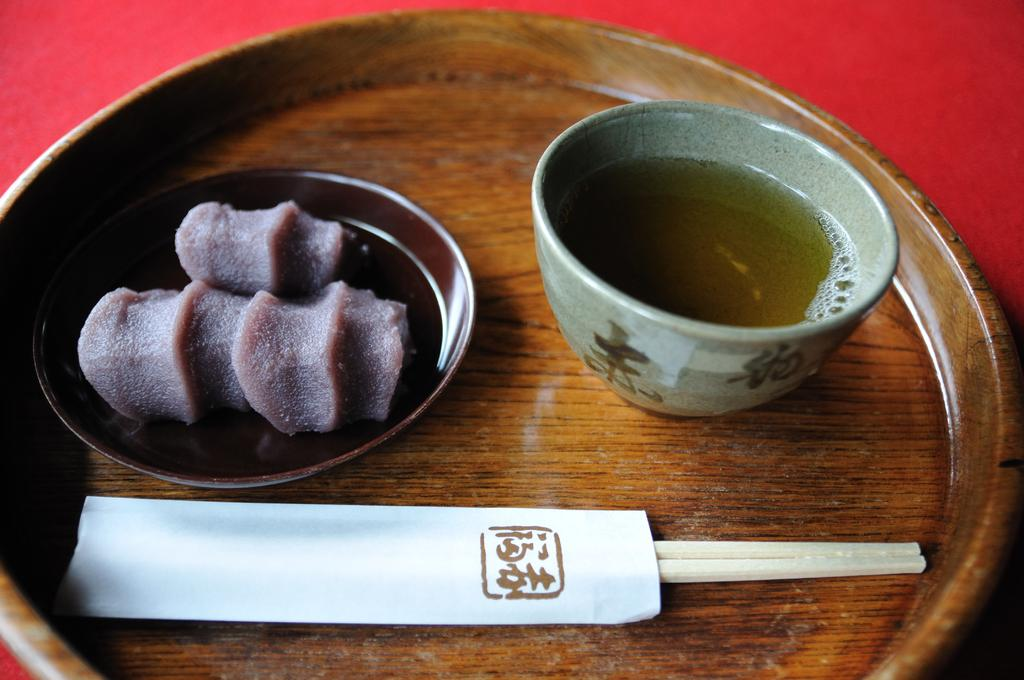What color is the table in the image? The table in the image is red. What is on the table in the image? There is a plate, two chopsticks, a bowl with syrup, and a plate with food on the table. How many chopsticks are on the table? There are two chopsticks on the table. What type of food is on the plate? The provided facts do not specify the type of food on the plate. How far away is the badge from the table in the image? There is no badge present in the image. Can you pull the syrup closer to the plate in the image? The image is a static representation, so it is not possible to interact with the objects in the image. 